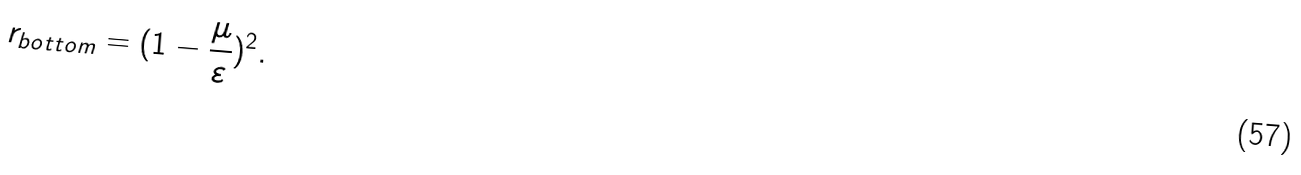<formula> <loc_0><loc_0><loc_500><loc_500>r _ { b o t t o m } = ( 1 - \frac { \mu } { \varepsilon } ) ^ { 2 } .</formula> 